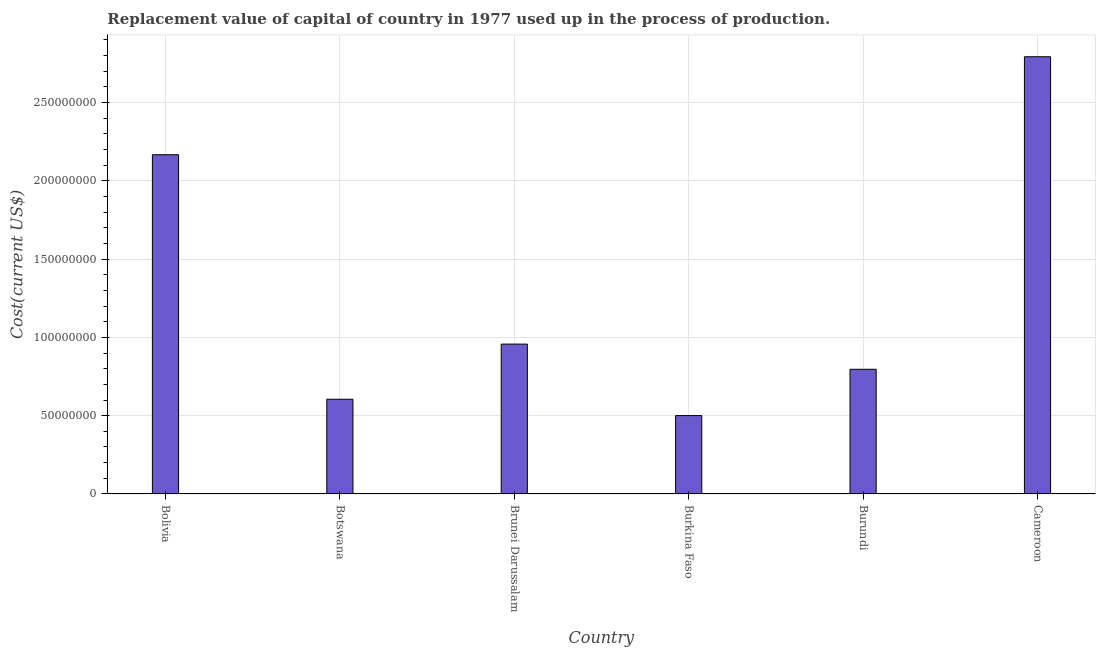Does the graph contain any zero values?
Offer a terse response. No. Does the graph contain grids?
Offer a very short reply. Yes. What is the title of the graph?
Keep it short and to the point. Replacement value of capital of country in 1977 used up in the process of production. What is the label or title of the X-axis?
Your response must be concise. Country. What is the label or title of the Y-axis?
Your answer should be compact. Cost(current US$). What is the consumption of fixed capital in Cameroon?
Offer a very short reply. 2.79e+08. Across all countries, what is the maximum consumption of fixed capital?
Give a very brief answer. 2.79e+08. Across all countries, what is the minimum consumption of fixed capital?
Your answer should be very brief. 5.01e+07. In which country was the consumption of fixed capital maximum?
Your answer should be very brief. Cameroon. In which country was the consumption of fixed capital minimum?
Keep it short and to the point. Burkina Faso. What is the sum of the consumption of fixed capital?
Offer a terse response. 7.82e+08. What is the difference between the consumption of fixed capital in Bolivia and Burundi?
Provide a short and direct response. 1.37e+08. What is the average consumption of fixed capital per country?
Make the answer very short. 1.30e+08. What is the median consumption of fixed capital?
Provide a succinct answer. 8.77e+07. What is the ratio of the consumption of fixed capital in Bolivia to that in Burkina Faso?
Provide a succinct answer. 4.33. Is the consumption of fixed capital in Botswana less than that in Cameroon?
Provide a short and direct response. Yes. Is the difference between the consumption of fixed capital in Botswana and Brunei Darussalam greater than the difference between any two countries?
Keep it short and to the point. No. What is the difference between the highest and the second highest consumption of fixed capital?
Ensure brevity in your answer.  6.26e+07. Is the sum of the consumption of fixed capital in Bolivia and Burkina Faso greater than the maximum consumption of fixed capital across all countries?
Offer a very short reply. No. What is the difference between the highest and the lowest consumption of fixed capital?
Offer a very short reply. 2.29e+08. In how many countries, is the consumption of fixed capital greater than the average consumption of fixed capital taken over all countries?
Provide a short and direct response. 2. What is the difference between two consecutive major ticks on the Y-axis?
Ensure brevity in your answer.  5.00e+07. What is the Cost(current US$) of Bolivia?
Give a very brief answer. 2.17e+08. What is the Cost(current US$) of Botswana?
Give a very brief answer. 6.05e+07. What is the Cost(current US$) in Brunei Darussalam?
Your answer should be very brief. 9.57e+07. What is the Cost(current US$) in Burkina Faso?
Give a very brief answer. 5.01e+07. What is the Cost(current US$) in Burundi?
Your answer should be very brief. 7.96e+07. What is the Cost(current US$) in Cameroon?
Your response must be concise. 2.79e+08. What is the difference between the Cost(current US$) in Bolivia and Botswana?
Your response must be concise. 1.56e+08. What is the difference between the Cost(current US$) in Bolivia and Brunei Darussalam?
Provide a short and direct response. 1.21e+08. What is the difference between the Cost(current US$) in Bolivia and Burkina Faso?
Ensure brevity in your answer.  1.67e+08. What is the difference between the Cost(current US$) in Bolivia and Burundi?
Offer a very short reply. 1.37e+08. What is the difference between the Cost(current US$) in Bolivia and Cameroon?
Your answer should be compact. -6.26e+07. What is the difference between the Cost(current US$) in Botswana and Brunei Darussalam?
Ensure brevity in your answer.  -3.52e+07. What is the difference between the Cost(current US$) in Botswana and Burkina Faso?
Offer a very short reply. 1.04e+07. What is the difference between the Cost(current US$) in Botswana and Burundi?
Give a very brief answer. -1.91e+07. What is the difference between the Cost(current US$) in Botswana and Cameroon?
Provide a short and direct response. -2.19e+08. What is the difference between the Cost(current US$) in Brunei Darussalam and Burkina Faso?
Provide a succinct answer. 4.57e+07. What is the difference between the Cost(current US$) in Brunei Darussalam and Burundi?
Make the answer very short. 1.61e+07. What is the difference between the Cost(current US$) in Brunei Darussalam and Cameroon?
Your response must be concise. -1.84e+08. What is the difference between the Cost(current US$) in Burkina Faso and Burundi?
Make the answer very short. -2.96e+07. What is the difference between the Cost(current US$) in Burkina Faso and Cameroon?
Offer a very short reply. -2.29e+08. What is the difference between the Cost(current US$) in Burundi and Cameroon?
Ensure brevity in your answer.  -2.00e+08. What is the ratio of the Cost(current US$) in Bolivia to that in Botswana?
Make the answer very short. 3.58. What is the ratio of the Cost(current US$) in Bolivia to that in Brunei Darussalam?
Provide a short and direct response. 2.26. What is the ratio of the Cost(current US$) in Bolivia to that in Burkina Faso?
Your answer should be very brief. 4.33. What is the ratio of the Cost(current US$) in Bolivia to that in Burundi?
Provide a succinct answer. 2.72. What is the ratio of the Cost(current US$) in Bolivia to that in Cameroon?
Your answer should be very brief. 0.78. What is the ratio of the Cost(current US$) in Botswana to that in Brunei Darussalam?
Provide a short and direct response. 0.63. What is the ratio of the Cost(current US$) in Botswana to that in Burkina Faso?
Provide a short and direct response. 1.21. What is the ratio of the Cost(current US$) in Botswana to that in Burundi?
Offer a very short reply. 0.76. What is the ratio of the Cost(current US$) in Botswana to that in Cameroon?
Your answer should be very brief. 0.22. What is the ratio of the Cost(current US$) in Brunei Darussalam to that in Burkina Faso?
Offer a very short reply. 1.91. What is the ratio of the Cost(current US$) in Brunei Darussalam to that in Burundi?
Give a very brief answer. 1.2. What is the ratio of the Cost(current US$) in Brunei Darussalam to that in Cameroon?
Offer a terse response. 0.34. What is the ratio of the Cost(current US$) in Burkina Faso to that in Burundi?
Make the answer very short. 0.63. What is the ratio of the Cost(current US$) in Burkina Faso to that in Cameroon?
Offer a terse response. 0.18. What is the ratio of the Cost(current US$) in Burundi to that in Cameroon?
Keep it short and to the point. 0.28. 